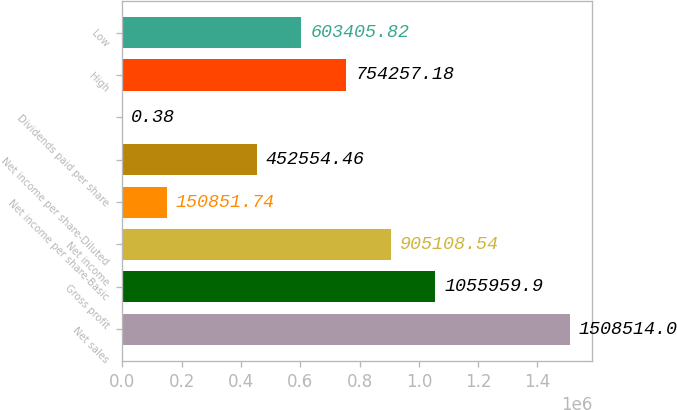Convert chart to OTSL. <chart><loc_0><loc_0><loc_500><loc_500><bar_chart><fcel>Net sales<fcel>Gross profit<fcel>Net income<fcel>Net income per share-Basic<fcel>Net income per share-Diluted<fcel>Dividends paid per share<fcel>High<fcel>Low<nl><fcel>1.50851e+06<fcel>1.05596e+06<fcel>905109<fcel>150852<fcel>452554<fcel>0.38<fcel>754257<fcel>603406<nl></chart> 